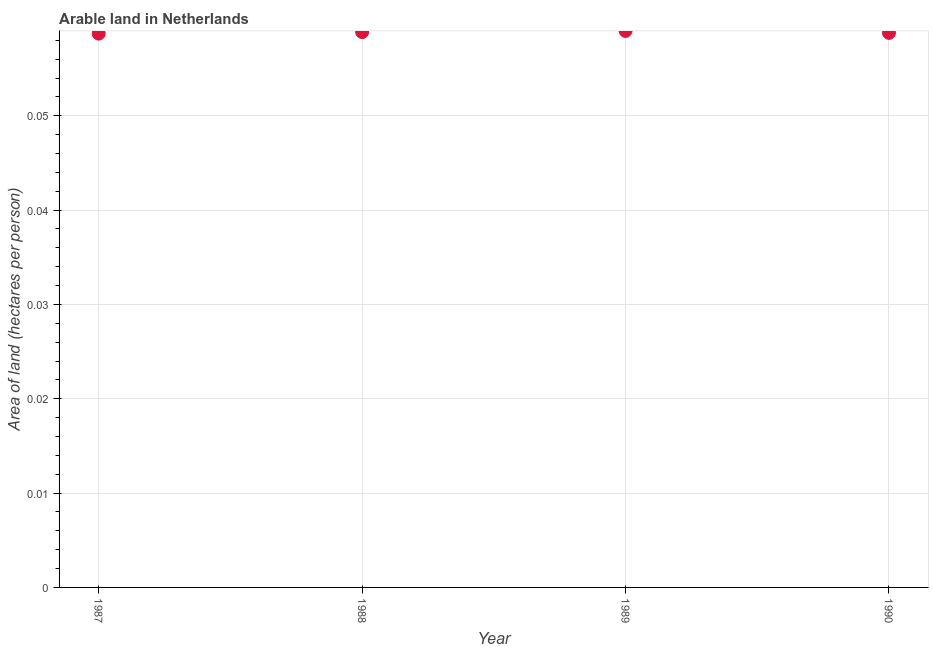What is the area of arable land in 1987?
Ensure brevity in your answer.  0.06. Across all years, what is the maximum area of arable land?
Provide a succinct answer. 0.06. Across all years, what is the minimum area of arable land?
Offer a very short reply. 0.06. In which year was the area of arable land maximum?
Offer a terse response. 1989. What is the sum of the area of arable land?
Your response must be concise. 0.24. What is the difference between the area of arable land in 1987 and 1989?
Keep it short and to the point. -0. What is the average area of arable land per year?
Give a very brief answer. 0.06. What is the median area of arable land?
Provide a short and direct response. 0.06. In how many years, is the area of arable land greater than 0.048 hectares per person?
Ensure brevity in your answer.  4. What is the ratio of the area of arable land in 1988 to that in 1990?
Your response must be concise. 1. What is the difference between the highest and the second highest area of arable land?
Offer a terse response. 0. Is the sum of the area of arable land in 1987 and 1988 greater than the maximum area of arable land across all years?
Make the answer very short. Yes. What is the difference between the highest and the lowest area of arable land?
Your answer should be very brief. 0. What is the difference between two consecutive major ticks on the Y-axis?
Keep it short and to the point. 0.01. Does the graph contain grids?
Give a very brief answer. Yes. What is the title of the graph?
Your answer should be very brief. Arable land in Netherlands. What is the label or title of the Y-axis?
Keep it short and to the point. Area of land (hectares per person). What is the Area of land (hectares per person) in 1987?
Ensure brevity in your answer.  0.06. What is the Area of land (hectares per person) in 1988?
Provide a succinct answer. 0.06. What is the Area of land (hectares per person) in 1989?
Offer a terse response. 0.06. What is the Area of land (hectares per person) in 1990?
Your answer should be very brief. 0.06. What is the difference between the Area of land (hectares per person) in 1987 and 1988?
Provide a short and direct response. -0. What is the difference between the Area of land (hectares per person) in 1987 and 1989?
Keep it short and to the point. -0. What is the difference between the Area of land (hectares per person) in 1987 and 1990?
Provide a succinct answer. -8e-5. What is the difference between the Area of land (hectares per person) in 1988 and 1989?
Give a very brief answer. -0. What is the difference between the Area of land (hectares per person) in 1988 and 1990?
Provide a short and direct response. 8e-5. What is the difference between the Area of land (hectares per person) in 1989 and 1990?
Your response must be concise. 0. What is the ratio of the Area of land (hectares per person) in 1987 to that in 1988?
Give a very brief answer. 1. What is the ratio of the Area of land (hectares per person) in 1987 to that in 1989?
Offer a terse response. 0.99. What is the ratio of the Area of land (hectares per person) in 1987 to that in 1990?
Your answer should be compact. 1. What is the ratio of the Area of land (hectares per person) in 1988 to that in 1989?
Ensure brevity in your answer.  1. What is the ratio of the Area of land (hectares per person) in 1988 to that in 1990?
Provide a short and direct response. 1. What is the ratio of the Area of land (hectares per person) in 1989 to that in 1990?
Your answer should be compact. 1. 